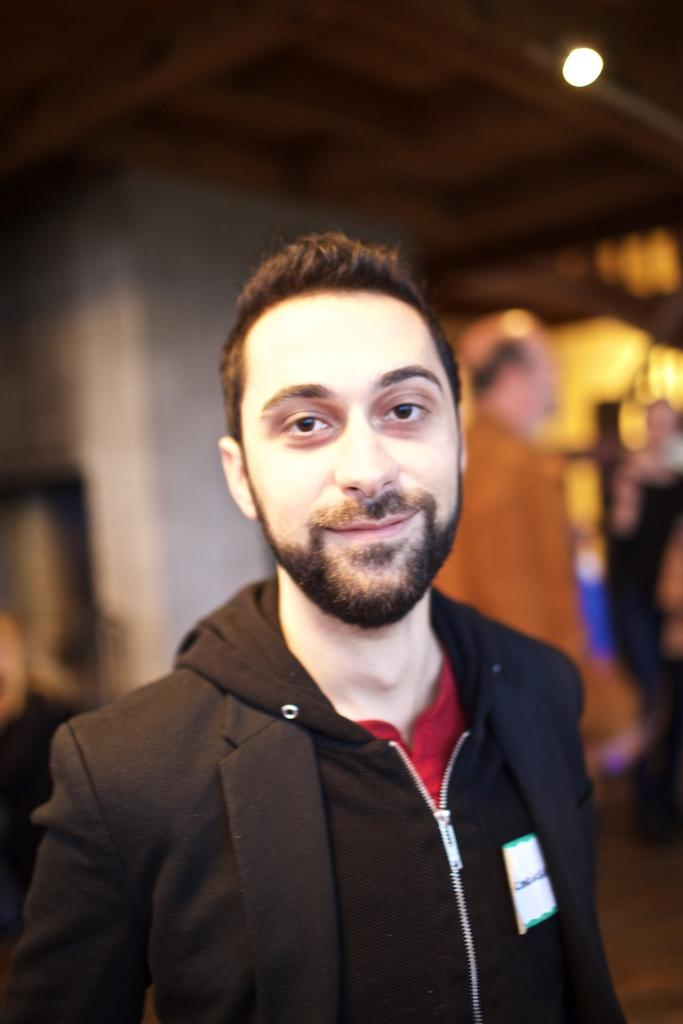Who is present in the image? There is a man in the image. What is the man doing in the image? The man is smiling in the image. Can you describe the person on the right side of the image? There is a person on the right side of the image, but their appearance is not specified in the facts. What can be seen at the top right side of the image? There is light at the top right side of the image. How would you describe the background of the image? The background of the image is blurry. What arithmetic problem is the man solving in the image? There is no indication in the image that the man is solving an arithmetic problem. What type of street is visible in the image? There is no street visible in the image. 